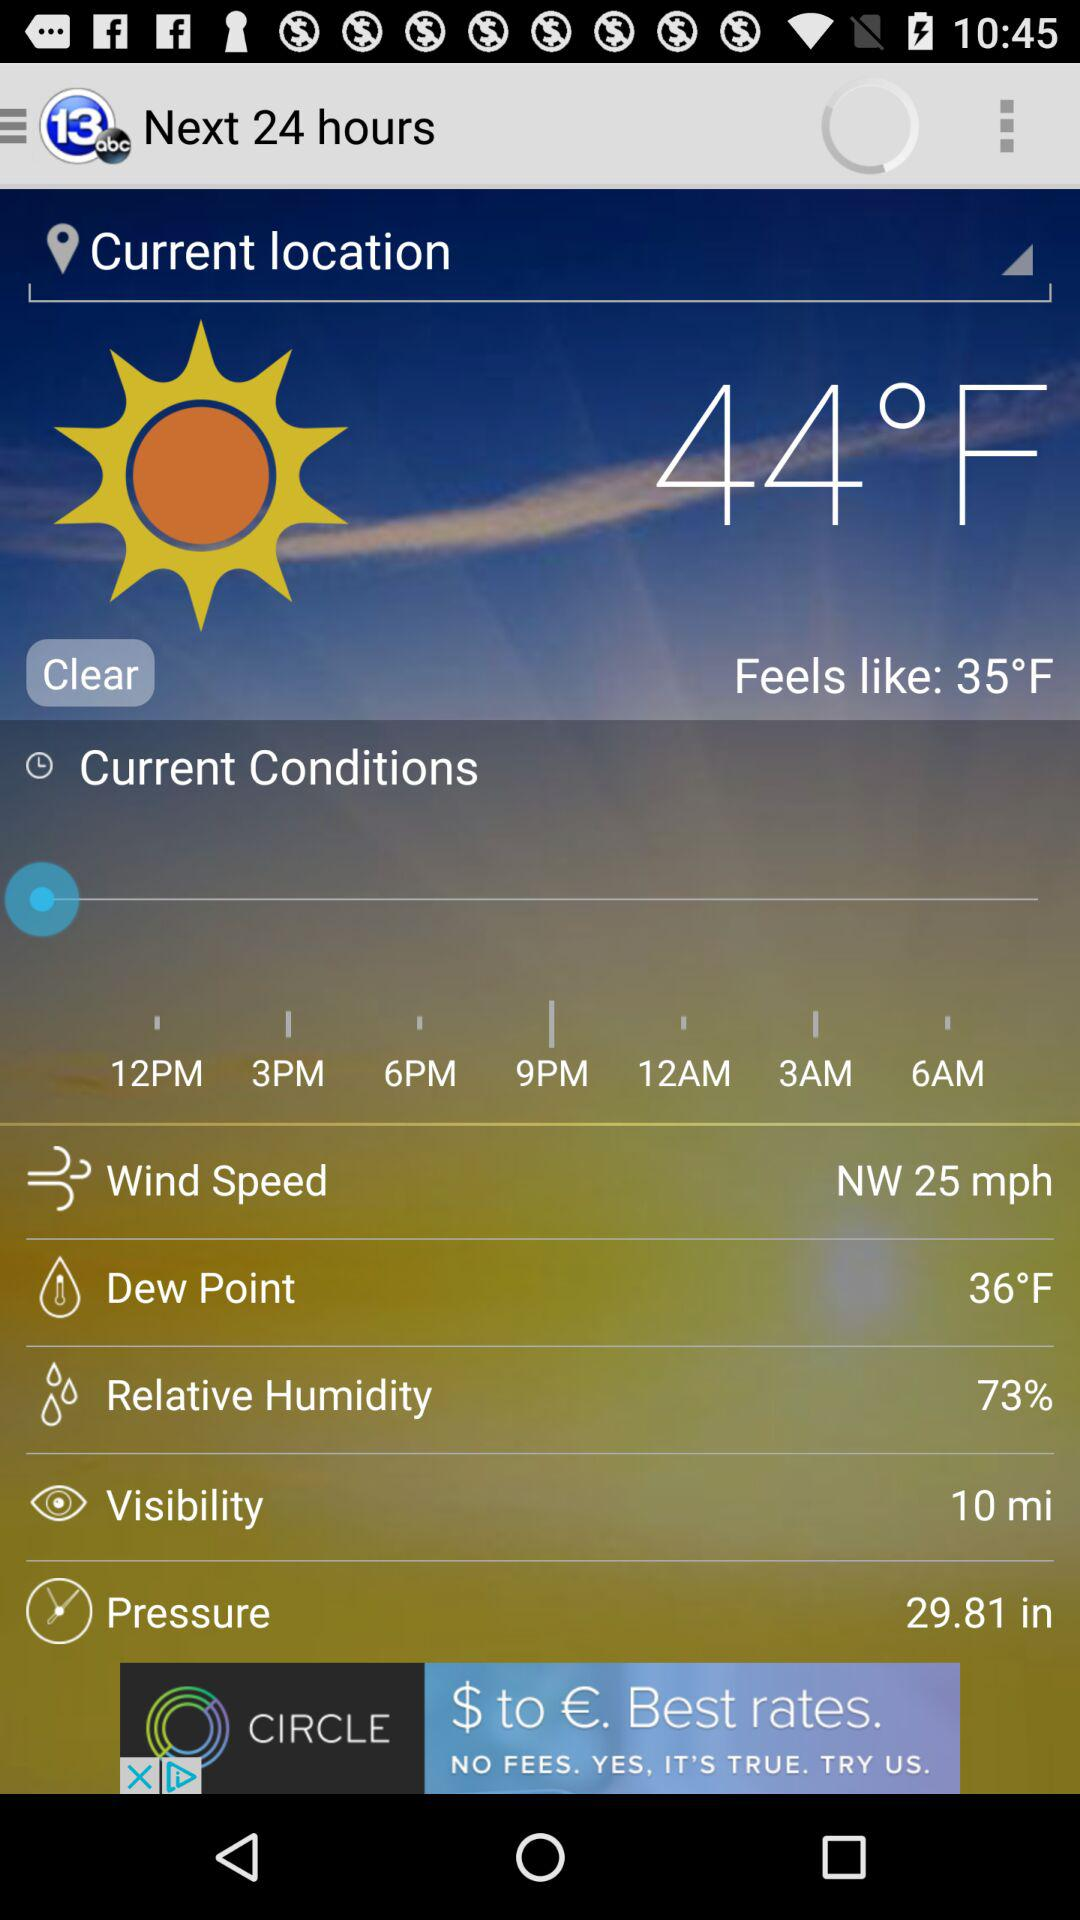What is the relative humidity? The relative humidity is 73%. 